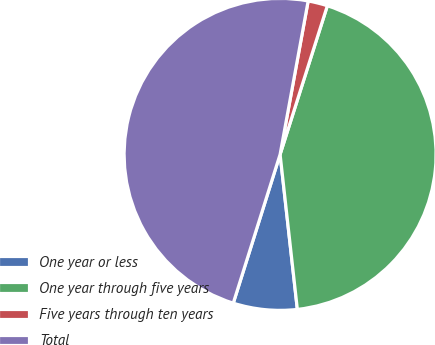<chart> <loc_0><loc_0><loc_500><loc_500><pie_chart><fcel>One year or less<fcel>One year through five years<fcel>Five years through ten years<fcel>Total<nl><fcel>6.62%<fcel>43.34%<fcel>2.02%<fcel>48.03%<nl></chart> 